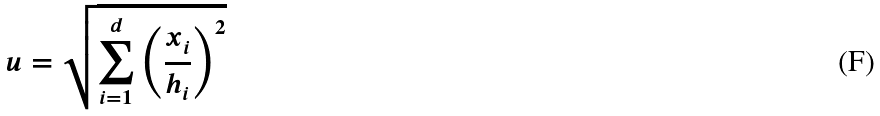Convert formula to latex. <formula><loc_0><loc_0><loc_500><loc_500>u = \sqrt { \sum _ { i = 1 } ^ { d } \left ( \frac { x _ { i } } { h _ { i } } \right ) ^ { 2 } }</formula> 